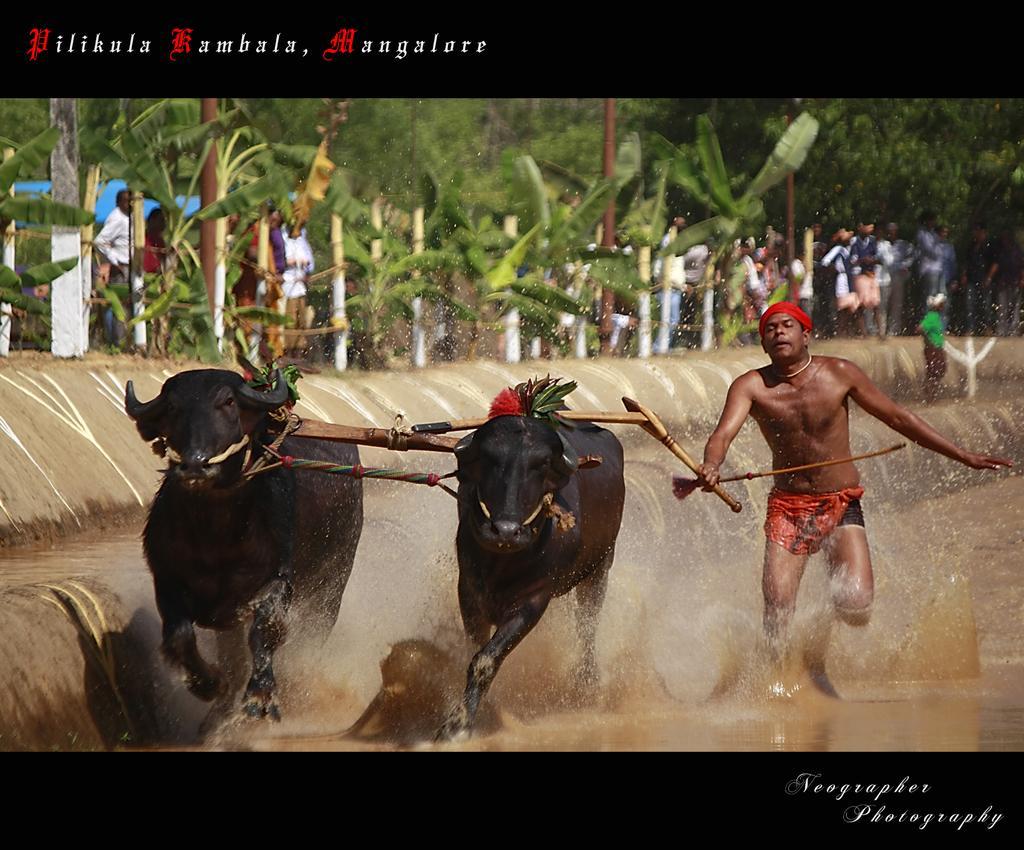Please provide a concise description of this image. In this image there are two bull, behind the bulls there is a men, in the bottom right there is a text written , in the top left there is a text written, in the background there are trees and people. 